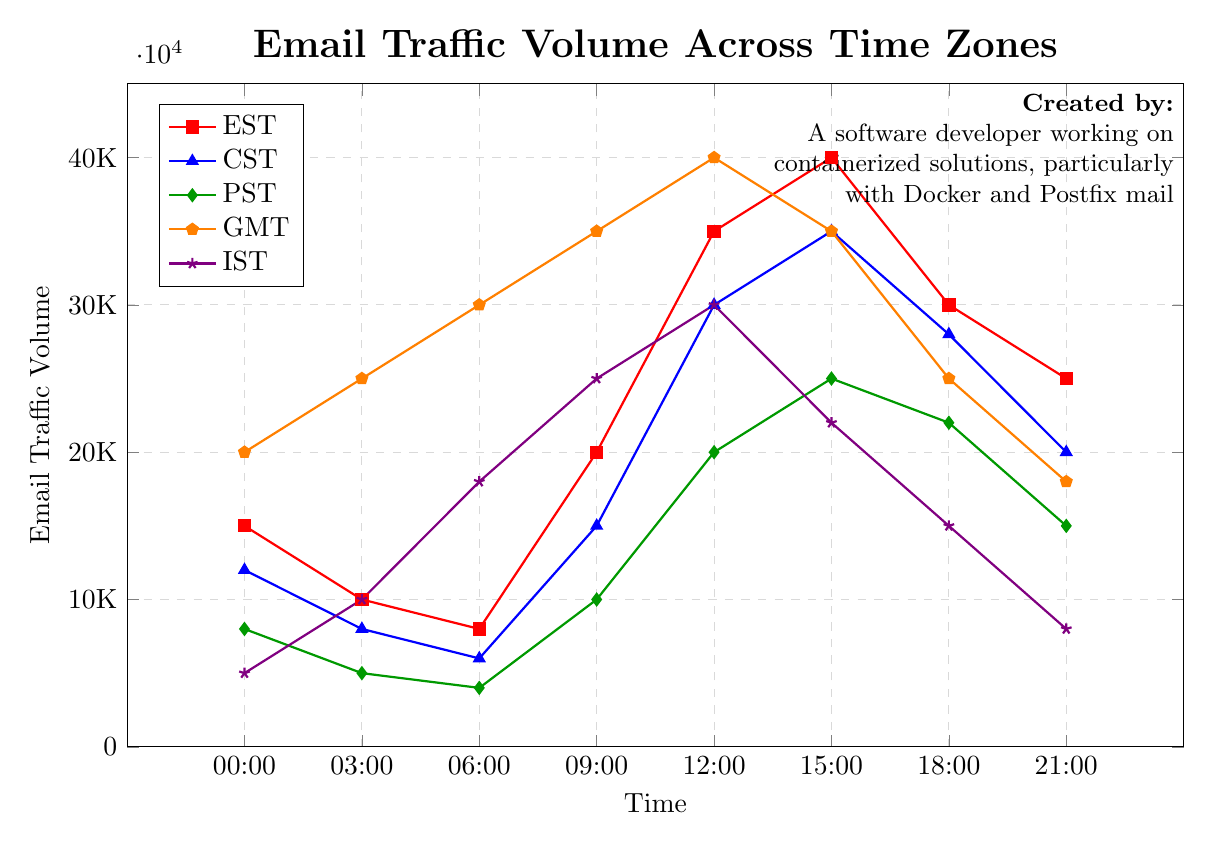What time zone has the highest email traffic volume at 12:00? By examining the plotted lines at 12:00, we can see which line reaches the highest point. The line labeled "GMT" is the highest at this hour.
Answer: GMT Which time zone has the least email traffic at 21:00? Look at the data points corresponding to 21:00 across all lines. The line labeled "IST" has the lowest value at this time.
Answer: IST What is the average email traffic volume for PST throughout the day? Add up the traffic volumes for PST at each time point: 8000 + 5000 + 4000 + 10000 + 20000 + 25000 + 22000 + 15000, then divide by the number of data points (8). This gives (104000/8).
Answer: 13000 At what time does EST experience its peak email traffic volume? Identify the highest point on the EST line by comparing the y-values. The highest value is at 15:00.
Answer: 15:00 How does the email traffic volume at 06:00 in IST compare to that in PST? Compare the y-values for IST and PST at 06:00. IST has a traffic volume of 18000, while PST has 4000. IST’s volume is much higher.
Answer: IST is greater What is the combined email traffic volume for CST and GMT at 18:00? Add the values for CST and GMT at 18:00: 28000 (CST) + 25000 (GMT) = 53000.
Answer: 53000 Which time zone shows a steady decline in email traffic volume from 12:00 to 21:00? Plot the trends for each time zone from 12:00 to 21:00. IST’s line consistently decreases during this window.
Answer: IST What is the difference in email traffic volume between CST and EST at 03:00? Subtract CST’s value from EST’s value at 03:00: 10000 (EST) - 8000 (CST) = 2000.
Answer: 2000 Which time zone experiences the most significant increase in email traffic volume between 06:00 and 09:00? Calculate the difference for each time zone between these times. GMT increases from 30000 to 35000, the largest change of 5000.
Answer: GMT What is the trend for GMT's email traffic from midnight to 06:00? Observing the GMT line from 00:00 to 06:00, the trend shows a consistent increase in traffic.
Answer: Increasing 